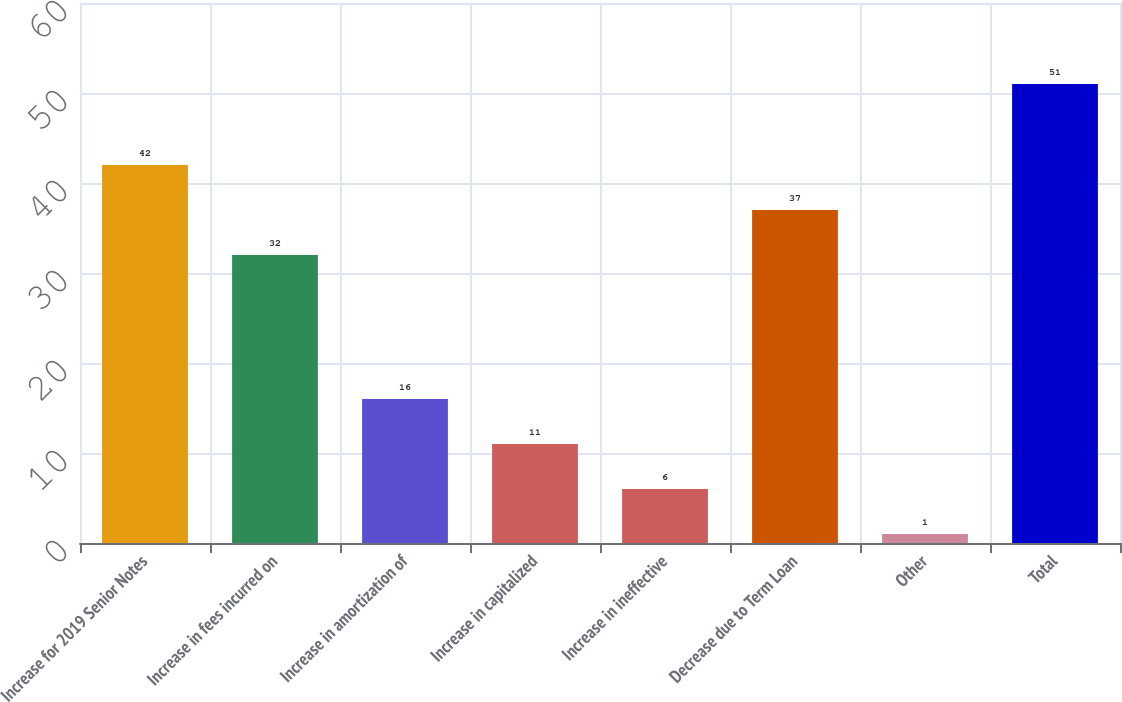<chart> <loc_0><loc_0><loc_500><loc_500><bar_chart><fcel>Increase for 2019 Senior Notes<fcel>Increase in fees incurred on<fcel>Increase in amortization of<fcel>Increase in capitalized<fcel>Increase in ineffective<fcel>Decrease due to Term Loan<fcel>Other<fcel>Total<nl><fcel>42<fcel>32<fcel>16<fcel>11<fcel>6<fcel>37<fcel>1<fcel>51<nl></chart> 